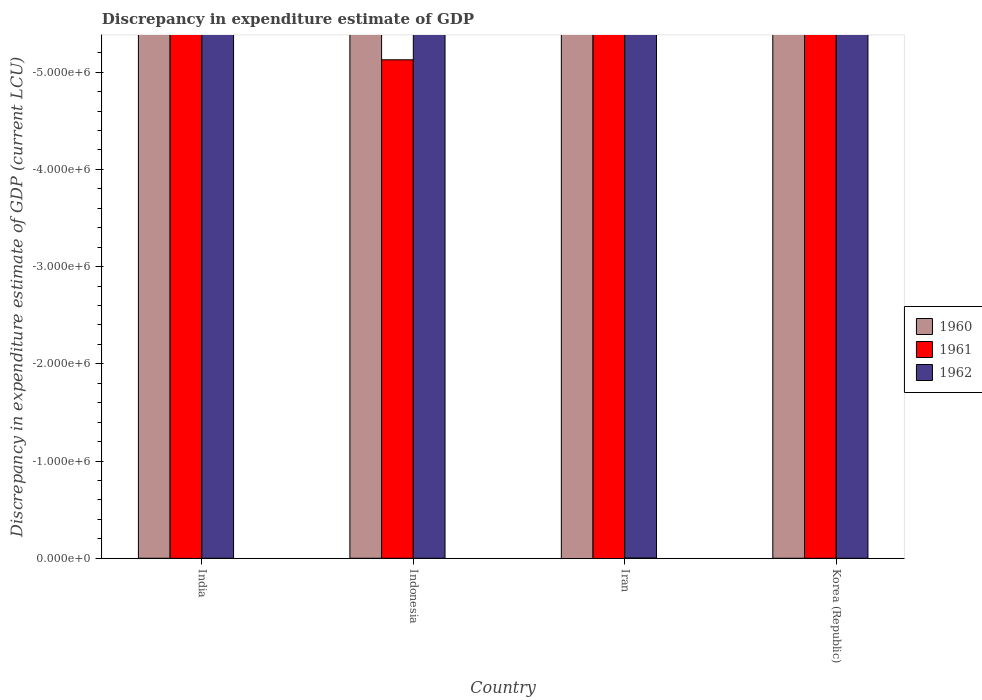How many different coloured bars are there?
Give a very brief answer. 0. Are the number of bars per tick equal to the number of legend labels?
Provide a short and direct response. No. How many bars are there on the 3rd tick from the right?
Provide a short and direct response. 0. What is the label of the 2nd group of bars from the left?
Your answer should be compact. Indonesia. In how many cases, is the number of bars for a given country not equal to the number of legend labels?
Provide a succinct answer. 4. What is the difference between the discrepancy in expenditure estimate of GDP in 1961 in Korea (Republic) and the discrepancy in expenditure estimate of GDP in 1962 in India?
Give a very brief answer. 0. In how many countries, is the discrepancy in expenditure estimate of GDP in 1962 greater than the average discrepancy in expenditure estimate of GDP in 1962 taken over all countries?
Provide a short and direct response. 0. Are the values on the major ticks of Y-axis written in scientific E-notation?
Your answer should be compact. Yes. Does the graph contain any zero values?
Your answer should be very brief. Yes. How are the legend labels stacked?
Your response must be concise. Vertical. What is the title of the graph?
Your answer should be very brief. Discrepancy in expenditure estimate of GDP. What is the label or title of the Y-axis?
Offer a terse response. Discrepancy in expenditure estimate of GDP (current LCU). What is the Discrepancy in expenditure estimate of GDP (current LCU) in 1961 in India?
Provide a short and direct response. 0. What is the Discrepancy in expenditure estimate of GDP (current LCU) in 1962 in Indonesia?
Your response must be concise. 0. What is the Discrepancy in expenditure estimate of GDP (current LCU) in 1962 in Iran?
Your response must be concise. 0. What is the total Discrepancy in expenditure estimate of GDP (current LCU) of 1962 in the graph?
Make the answer very short. 0. What is the average Discrepancy in expenditure estimate of GDP (current LCU) in 1961 per country?
Offer a very short reply. 0. What is the average Discrepancy in expenditure estimate of GDP (current LCU) in 1962 per country?
Your answer should be very brief. 0. 